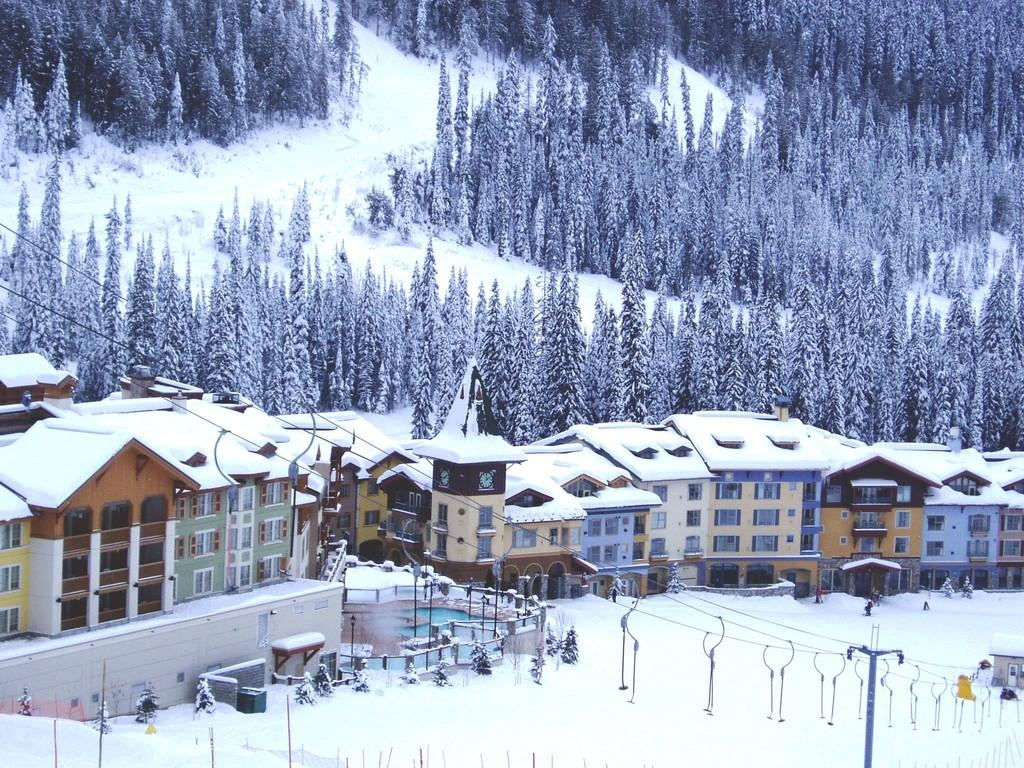What type of structures can be seen in the image? There are buildings in the image. What else is present in the image besides the buildings? There is a pole and wires in the image. What is the condition of the ground in the image? There is snow on the ground. What can be seen in the background of the image? Trees covered with snow are visible in the background of the image. What is the level of wealth depicted in the image? The level of wealth cannot be determined from the image, as it only shows buildings, a pole, wires, snow on the ground, and snow-covered trees in the background. 